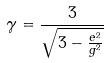Convert formula to latex. <formula><loc_0><loc_0><loc_500><loc_500>\gamma = \frac { 3 } { \sqrt { 3 - \frac { e ^ { 2 } } { g ^ { 2 } } } }</formula> 